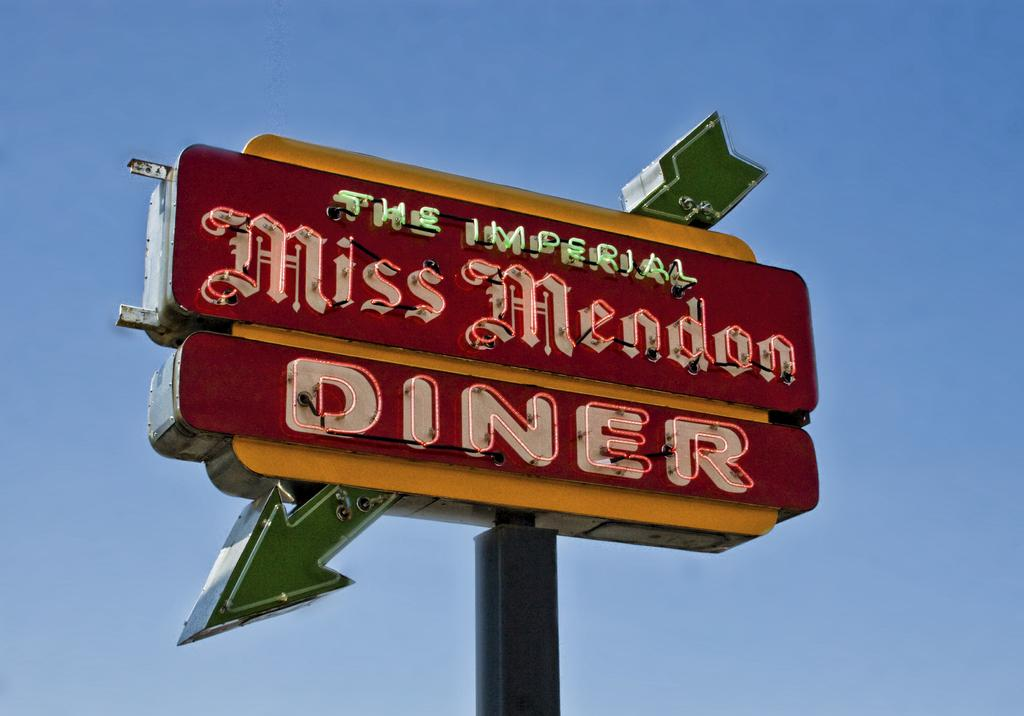<image>
Present a compact description of the photo's key features. Diner sign that says "The Imperial" on top in green. 